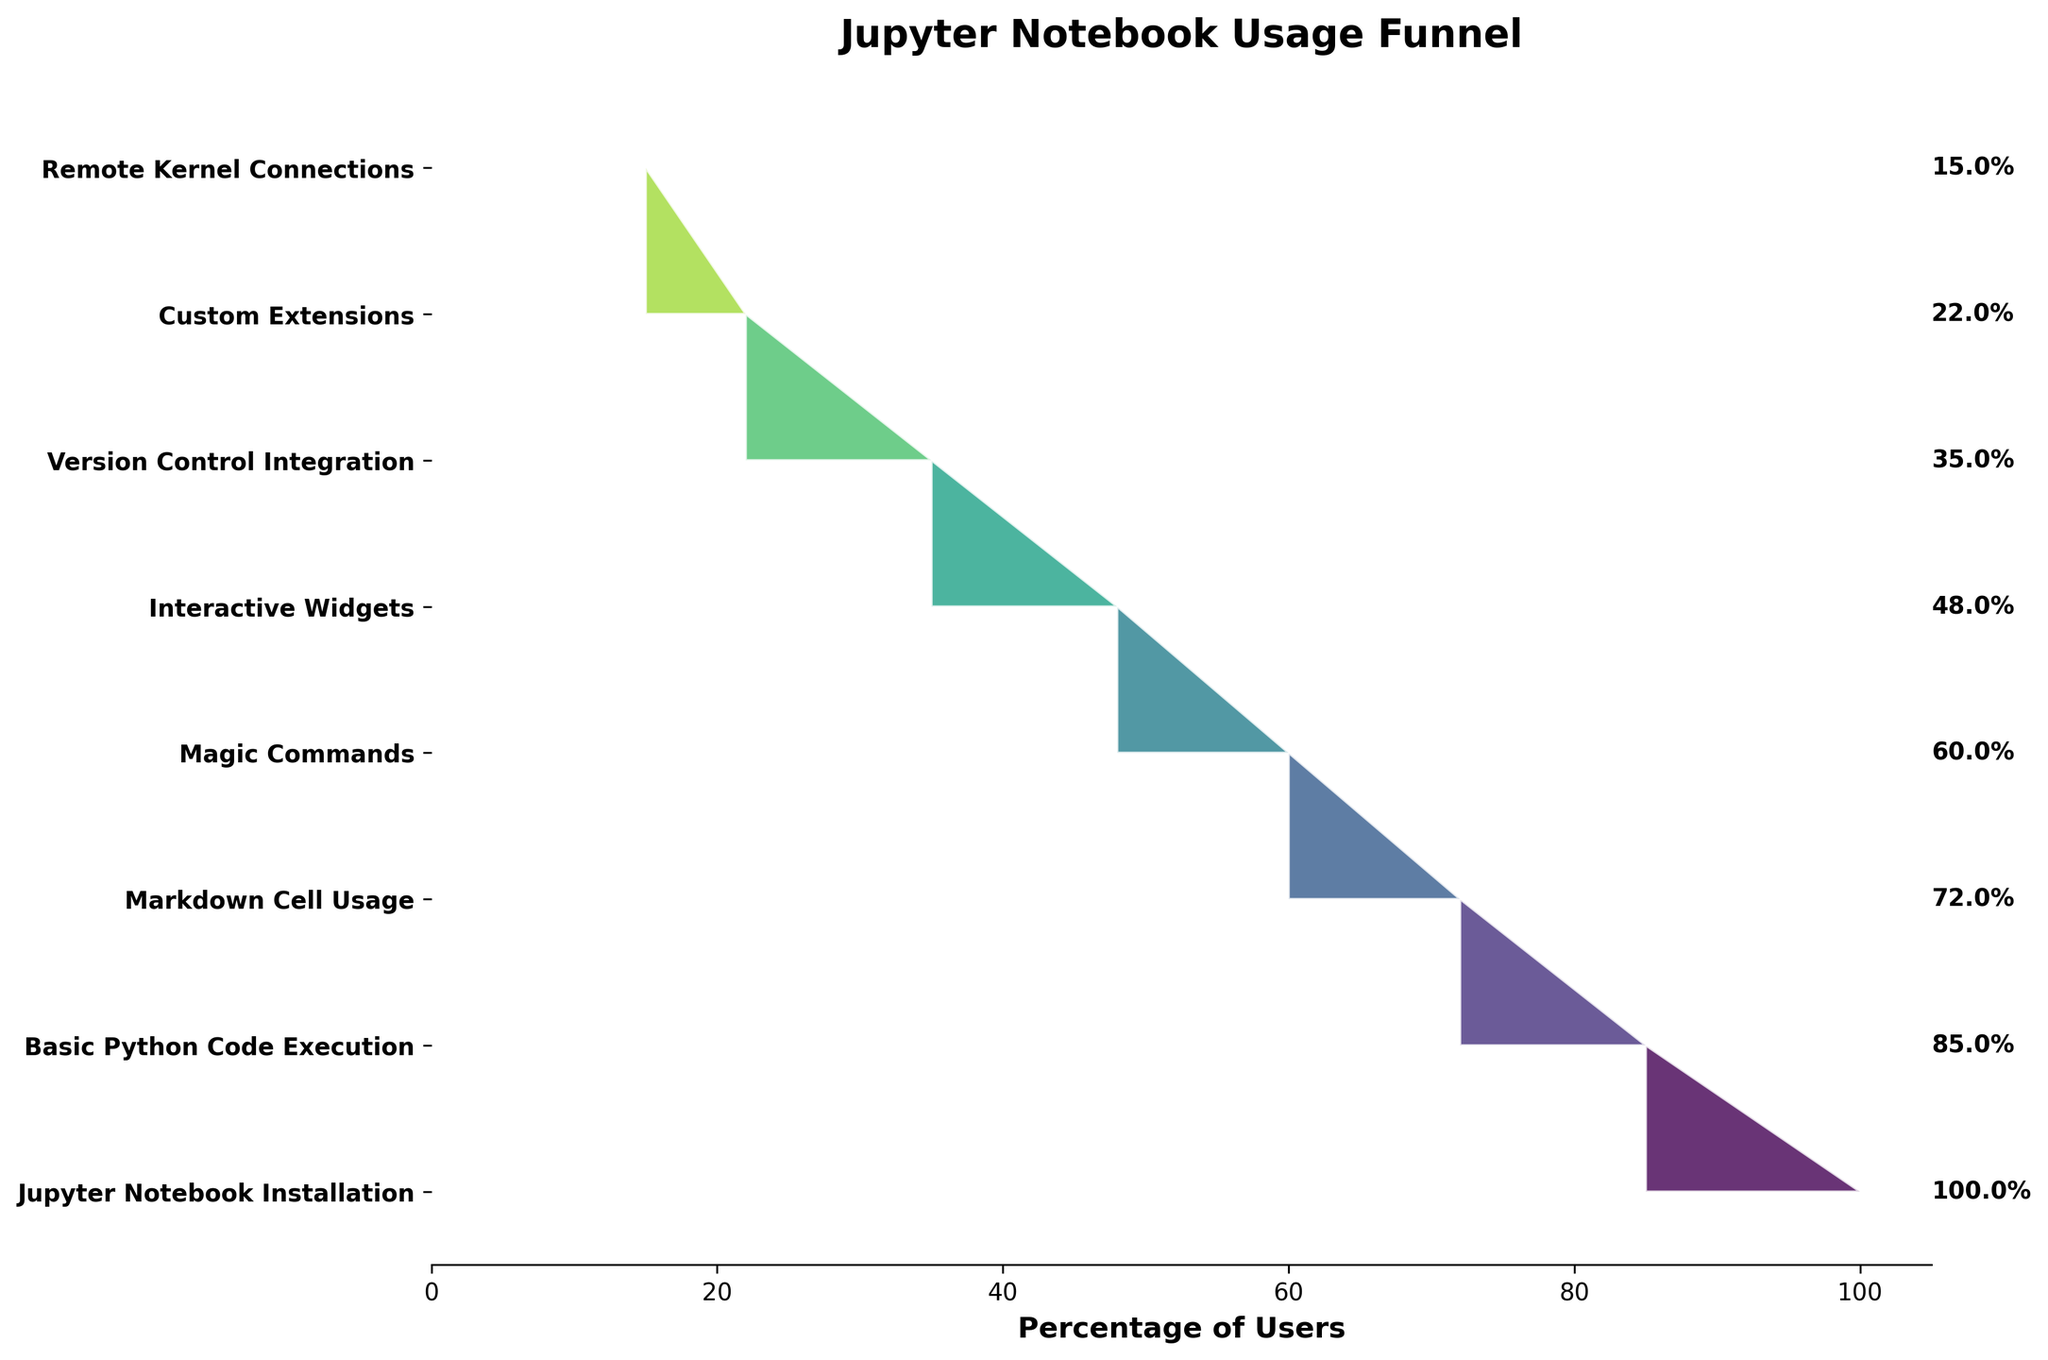What is the title of the funnel chart? The title is prominently displayed at the top of the figure. It is "Jupyter Notebook Usage Funnel."
Answer: Jupyter Notebook Usage Funnel How many stages are represented in the funnel? By counting the number of distinct y-ticks or stages labeled on the y-axis, we see there are 8 stages.
Answer: 8 Which stage has the highest number of users? The highest number of users is displayed at the first stage of the funnel, listed as "Jupyter Notebook Installation" with 10,000 users.
Answer: Jupyter Notebook Installation What percentage of users utilize Magic Commands? Look at the percentage displayed next to the "Magic Commands" stage. It is 60.0%.
Answer: 60.0% How many users proceeded from "Version Control Integration" to "Custom Extensions"? The number of users at "Custom Extensions" stage is labeled as 2,200, right below the "Version Control Integration" stage which has 3,500 users. The difference of the two determines how many users dropped off, so the remaining number moved to the next stage.
Answer: 2,200 Which stage sees the greatest drop in user numbers? The greatest drop is quantified by the difference between stages. From "Version Control Integration" (3,500) to "Custom Extensions" (2,200) is a drop of 1,300 users, larger than any other drop between stages.
Answer: Version Control Integration to Custom Extensions What is the percentage drop from "Interactive Widgets" to "Version Control Integration"? First calculate the number of users, which is from 4,800 (Interactive Widgets) to 3,500 (Version Control Integration). Then convert this to a percentage of 4,800: (4,800-3,500)/4,800 * 100 = 27.1%.
Answer: 27.1% How many fewer users use Remote Kernel Connections compared to Custom Extensions? By comparing user numbers for "Custom Extensions" (2,200) and "Remote Kernel Connections" (1,500), the difference is 700.
Answer: 700 What is the average number of users from "Basic Python Code Execution" to "Remote Kernel Connections"? Sum the user counts from "Basic Python Code Execution" (8,500), "Markdown Cell Usage" (7,200), "Magic Commands" (6,000), "Interactive Widgets" (4,800), "Version Control Integration" (3,500), "Custom Extensions" (2,200), and "Remote Kernel Connections" (1,500), then divide by the number of stages, 7. The total sum is 33,700. 33,700 / 7 = 4,814.3.
Answer: 4,814.3 Is the drop from "Basic Python Code Execution" to "Markdown Cell Usage" greater than the drop from "Interactive Widgets" to "Version Control Integration"? The drop from "Basic Python Code Execution" (8,500) to "Markdown Cell Usage" (7,200) is 1,300. The drop from "Interactive Widgets" (4,800) to "Version Control Integration" (3,500) is also 1,300. Therefore, they are equal.
Answer: No 